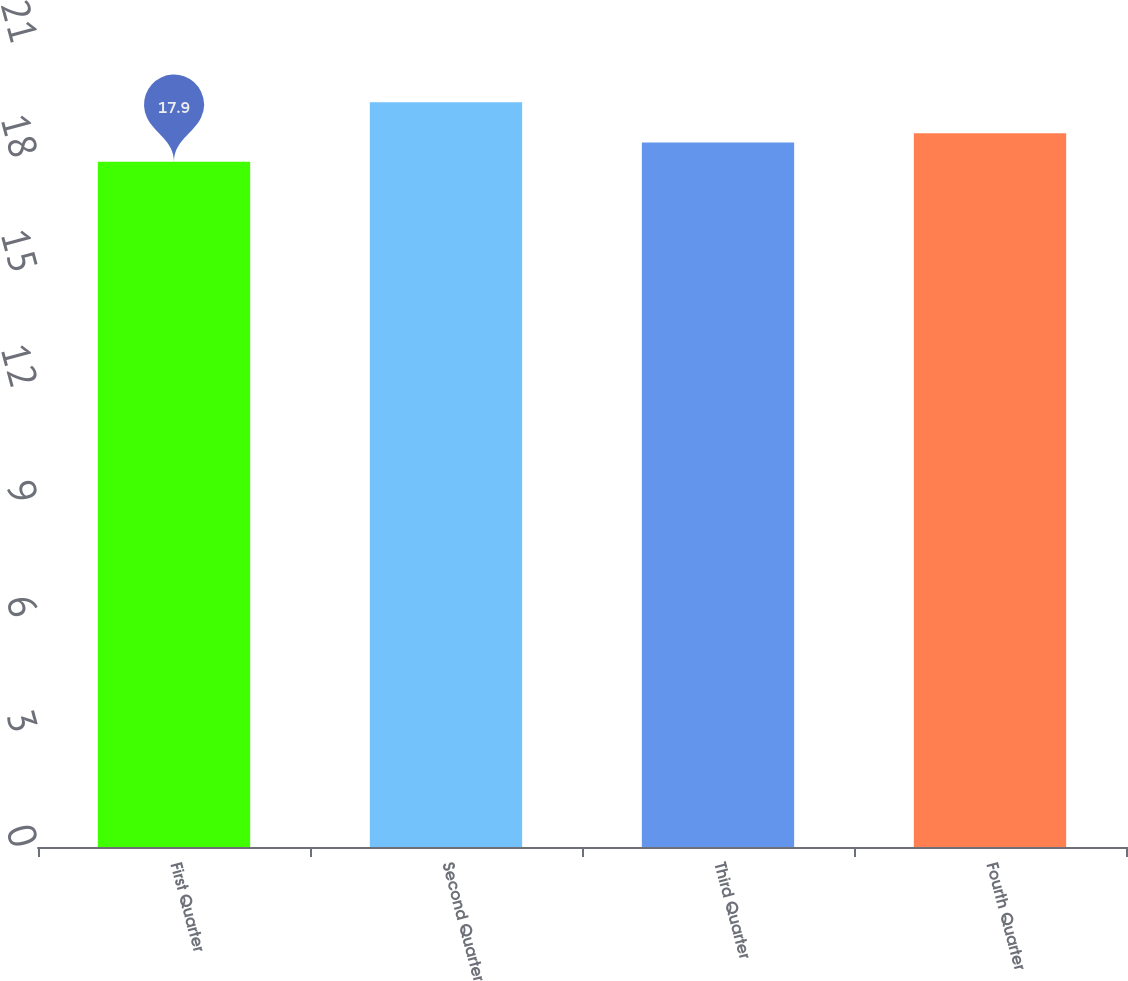Convert chart to OTSL. <chart><loc_0><loc_0><loc_500><loc_500><bar_chart><fcel>First Quarter<fcel>Second Quarter<fcel>Third Quarter<fcel>Fourth Quarter<nl><fcel>17.9<fcel>19.45<fcel>18.4<fcel>18.64<nl></chart> 